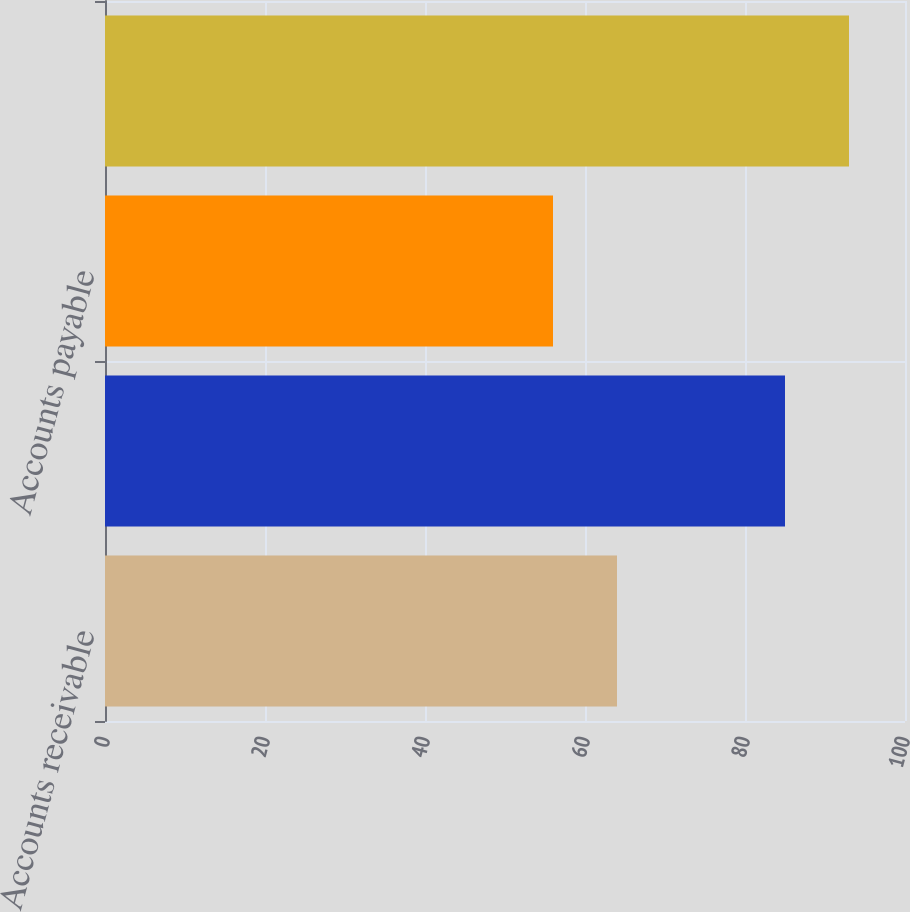Convert chart to OTSL. <chart><loc_0><loc_0><loc_500><loc_500><bar_chart><fcel>Accounts receivable<fcel>Inventory<fcel>Accounts payable<fcel>Cash conversion cycle<nl><fcel>64<fcel>85<fcel>56<fcel>93<nl></chart> 